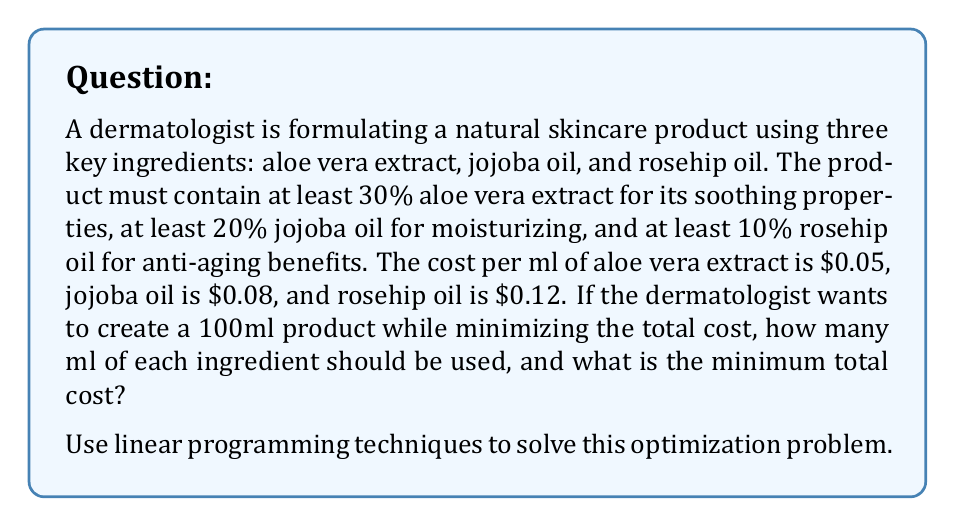Solve this math problem. Let's approach this problem using linear programming:

1) Define variables:
   Let $x_1$ = ml of aloe vera extract
   Let $x_2$ = ml of jojoba oil
   Let $x_3$ = ml of rosehip oil

2) Objective function:
   Minimize $Z = 0.05x_1 + 0.08x_2 + 0.12x_3$

3) Constraints:
   $x_1 + x_2 + x_3 = 100$ (total volume)
   $x_1 \geq 30$ (at least 30% aloe vera)
   $x_2 \geq 20$ (at least 20% jojoba oil)
   $x_3 \geq 10$ (at least 10% rosehip oil)
   $x_1, x_2, x_3 \geq 0$ (non-negativity)

4) Solving the linear programming problem:
   The minimum cost will occur at one of the extreme points of the feasible region. The extreme points are:
   
   a) (30, 20, 50)
   b) (30, 60, 10)
   c) (70, 20, 10)

5) Calculate the cost for each point:
   a) $Z = 0.05(30) + 0.08(20) + 0.12(50) = 9.1$
   b) $Z = 0.05(30) + 0.08(60) + 0.12(10) = 7.5$
   c) $Z = 0.05(70) + 0.08(20) + 0.12(10) = 6.1$

6) The minimum cost occurs at point c: (70, 20, 10)

Therefore, the optimal composition is:
- 70 ml of aloe vera extract
- 20 ml of jojoba oil
- 10 ml of rosehip oil

The minimum total cost is $6.1 for 100 ml of the product.
Answer: The optimal composition is 70 ml of aloe vera extract, 20 ml of jojoba oil, and 10 ml of rosehip oil. The minimum total cost is $6.1 for 100 ml of the product. 